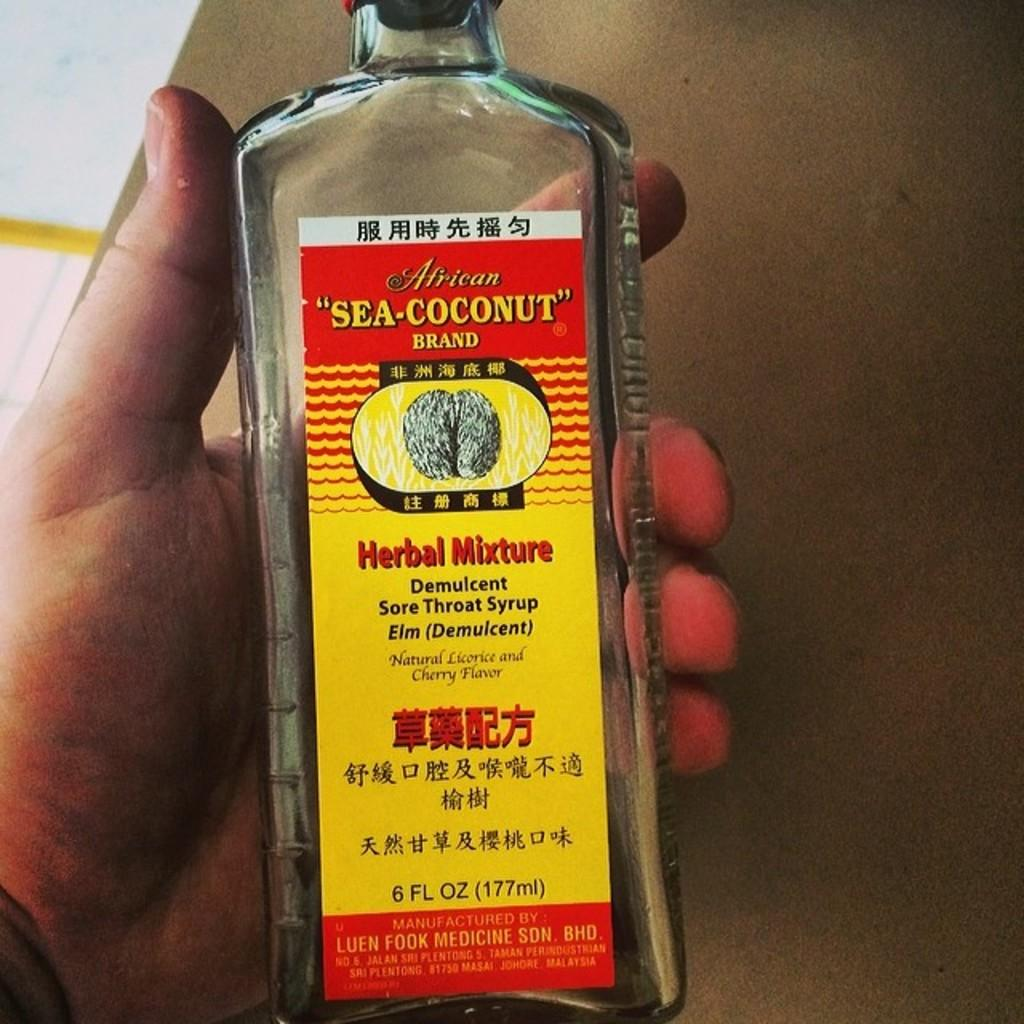<image>
Write a terse but informative summary of the picture. A Herbal mixture of a sore throat syrup is held in one hand. 